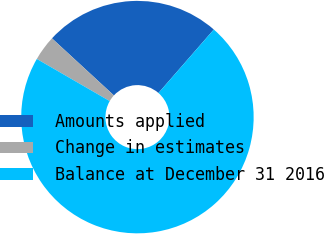Convert chart to OTSL. <chart><loc_0><loc_0><loc_500><loc_500><pie_chart><fcel>Amounts applied<fcel>Change in estimates<fcel>Balance at December 31 2016<nl><fcel>24.56%<fcel>3.51%<fcel>71.93%<nl></chart> 